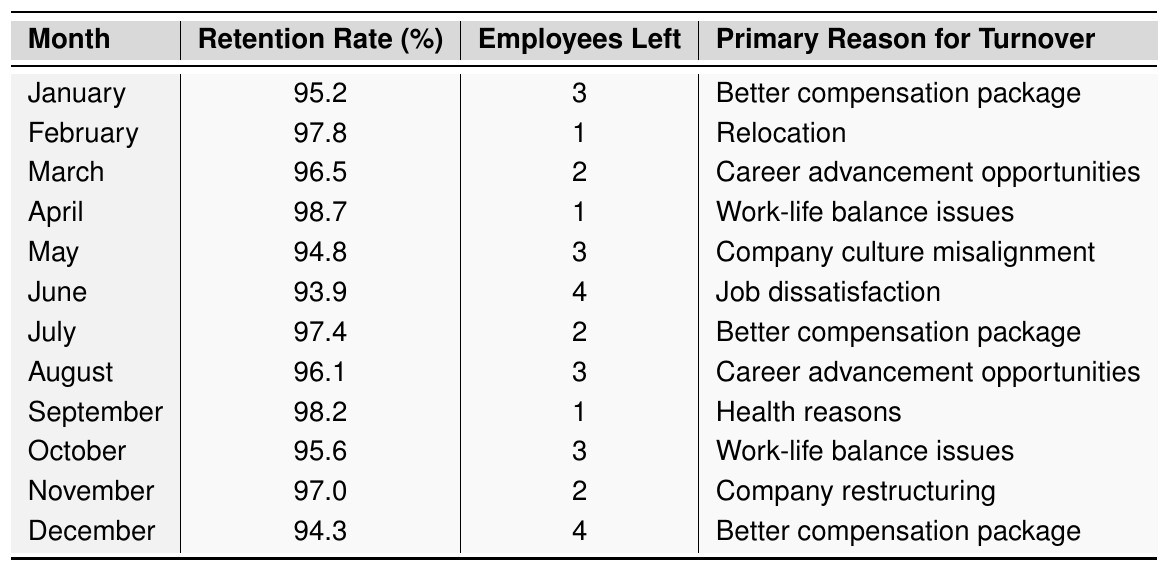What is the retention rate for April? In the table, the month of April is associated with a retention rate of 98.7%.
Answer: 98.7% How many employees left in June? According to the table, the number of employees who left in June is 4.
Answer: 4 What is the primary reason for turnover in September? The table indicates that the primary reason for turnover in September is health reasons.
Answer: Health reasons Which month had the lowest retention rate? By reviewing the retention rates, June shows the lowest rate at 93.9%.
Answer: June What is the average retention rate from January to December? The average retention rate can be calculated by adding all the retention rates (95.2 + 97.8 + 96.5 + 98.7 + 94.8 + 93.9 + 97.4 + 96.1 + 98.2 + 95.6 + 97.0 + 94.3 = 1,155.5) and dividing by the number of months (12). Thus, the average is 1,155.5 / 12 = 96.3%.
Answer: 96.3% How many employees have left for "better compensation package" across all months? The table shows that employees left for "better compensation package" in January (3), July (2), and December (4). Summing these gives 3 + 2 + 4 = 9.
Answer: 9 Is it true that a higher retention rate correlates with fewer employees leaving? Analyzing the data, we see that the months with retention rates above 97% generally have fewer employees leaving. For example, February (97.8% with 1 left) and April (98.7% with 1 left) support this observation, but while June has the lowest retention (93.9%) with the highest number (4) leaving, indicating a correlation exists.
Answer: True For which month did "work-life balance issues" cause turnover? Looking at the table, "work-life balance issues" caused turnover in April and October.
Answer: April and October What was the primary reason for turnover in the month with the highest retention rate? Referring to the table, April has the highest retention rate (98.7%), and the primary reason for turnover in that month was work-life balance issues.
Answer: Work-life balance issues What was the overall trend in retention rates from January to December? By examining the retention rates month by month, we can see fluctuations, but generally, they remain high, with slight dips in May and June. This suggests overall good employee retention, despite a few variations.
Answer: Generally high with fluctuations Which month saw the most employees leaving, and what was the reason? By checking the data, June had the most employees leaving at 4, primarily due to job dissatisfaction.
Answer: June, job dissatisfaction 